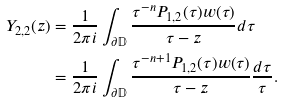Convert formula to latex. <formula><loc_0><loc_0><loc_500><loc_500>Y _ { 2 , 2 } ( z ) & = \frac { 1 } { 2 \pi i } \int _ { \partial \mathbb { D } } \frac { \tau ^ { - n } P _ { 1 , 2 } ( \tau ) w ( \tau ) } { \tau - z } d \tau \\ & = \frac { 1 } { 2 \pi i } \int _ { \partial \mathbb { D } } \frac { \tau ^ { - n + 1 } P _ { 1 , 2 } ( \tau ) w ( \tau ) } { \tau - z } \frac { d \tau } { \tau } .</formula> 